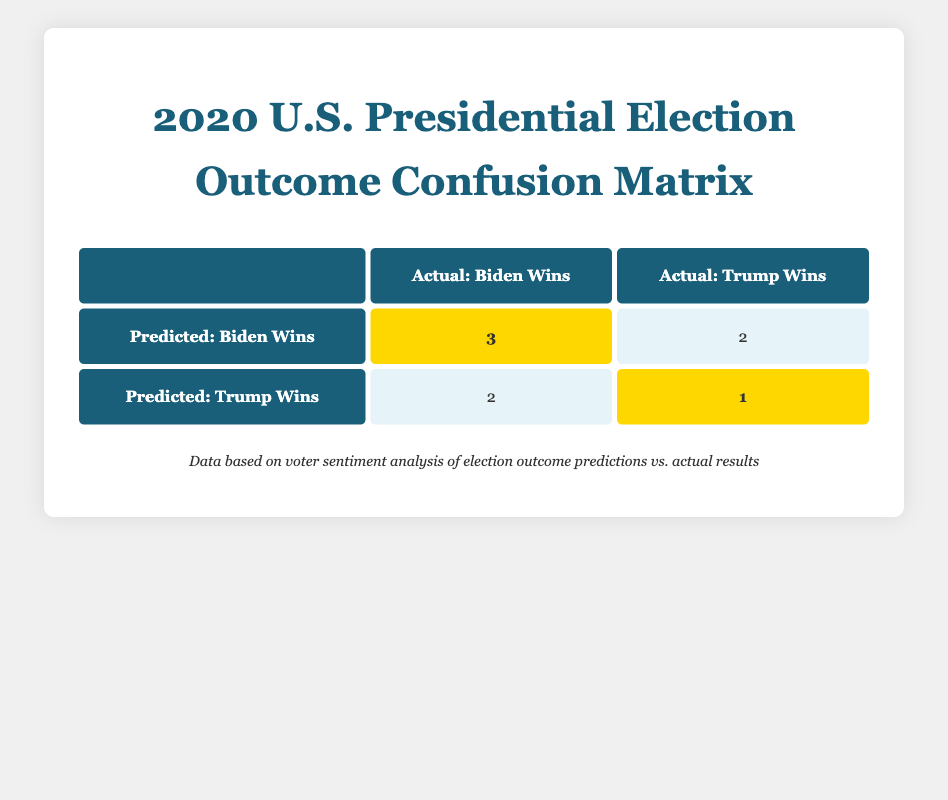What is the total number of predictions made for Joe Biden winning? From the table, we can see that there are three predictions that Joe Biden would win and the outcomes matched this prediction. There are two additional predictions where the outcome was actually Donald Trump winning, but these do not count toward the number of predictions for Joe Biden winning. Therefore, only the first predictions should be counted.
Answer: 3 How many times did the model predict that Donald Trump would win? In the table, there are two instances listed as predictions for Donald Trump winning. However, only one of those matched the actual outcome where Donald Trump also won.
Answer: 2 What is the number of actual outcomes where Joe Biden won? The table shows that there are 3 instances where the actual outcome aligns with predictions for Joe Biden winning (the highlighted cell in the table). Therefore, we can state there were 3 instances where Biden won.
Answer: 3 Is it true that the sentiment for all predictions of Biden winning was positive? Looking closely at the table, we see that there are predictions where Joe Biden was stated to win but the actual outcome showed Donald Trump winning, which indicate a negative sentiment. Therefore, it is false that all predictions for Biden were positive.
Answer: No What is the difference between the number of actual outcomes where Donald Trump won and the predictions that he would win? Evaluating the table reveals there was one actual outcome where Donald Trump won and two predictions that he would win. The difference is calculated as: 2 (predictions) - 1 (actual) = 1.
Answer: 1 How many total predictions were made, and what percentage were correct? The total number of predictions made can be found by counting each prediction in the table, which equals 8. The correct predictions for Biden winning are 3 (from the positive sentiment), and for Trump winning, there is 1. Therefore, the percentage of correct predictions is (4 correct / 8 total) x 100 = 50%.
Answer: 50% What is the total number of incorrect predictions made? The total number of incorrect predictions made can be derived from observing the table. There are 2 predictions for Biden winning that were incorrect, plus 2 predictions for Trump winning that were incorrect. Therefore, the total incorrect predictions are calculated as 2 + 2 = 4.
Answer: 4 What does the ratio of correct predictions for each candidate indicate about sentiment analysis? Counting from the table, Joe Biden had 3 correct predictions while Donald Trump had 1. This indicates that there was a higher level of sentiment supporting Biden, as more predictions accurately identified him as the winner, leading to a ratio of 3:1 in favor of Biden.
Answer: 3:1 